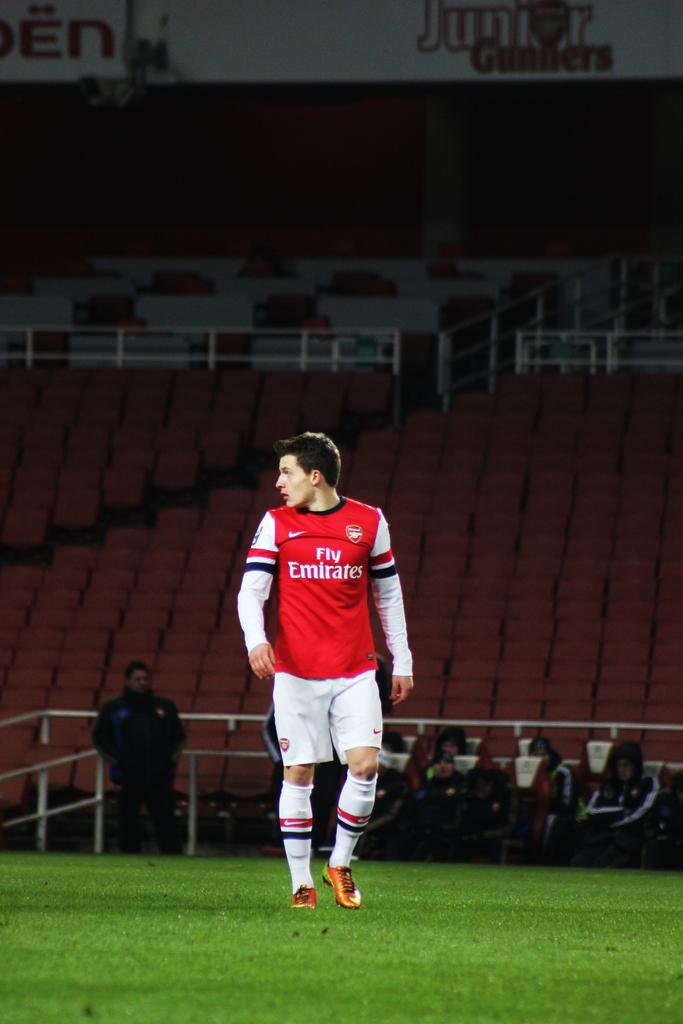<image>
Share a concise interpretation of the image provided. The football player for Arsenal is sponsored by Fly Emerates. 